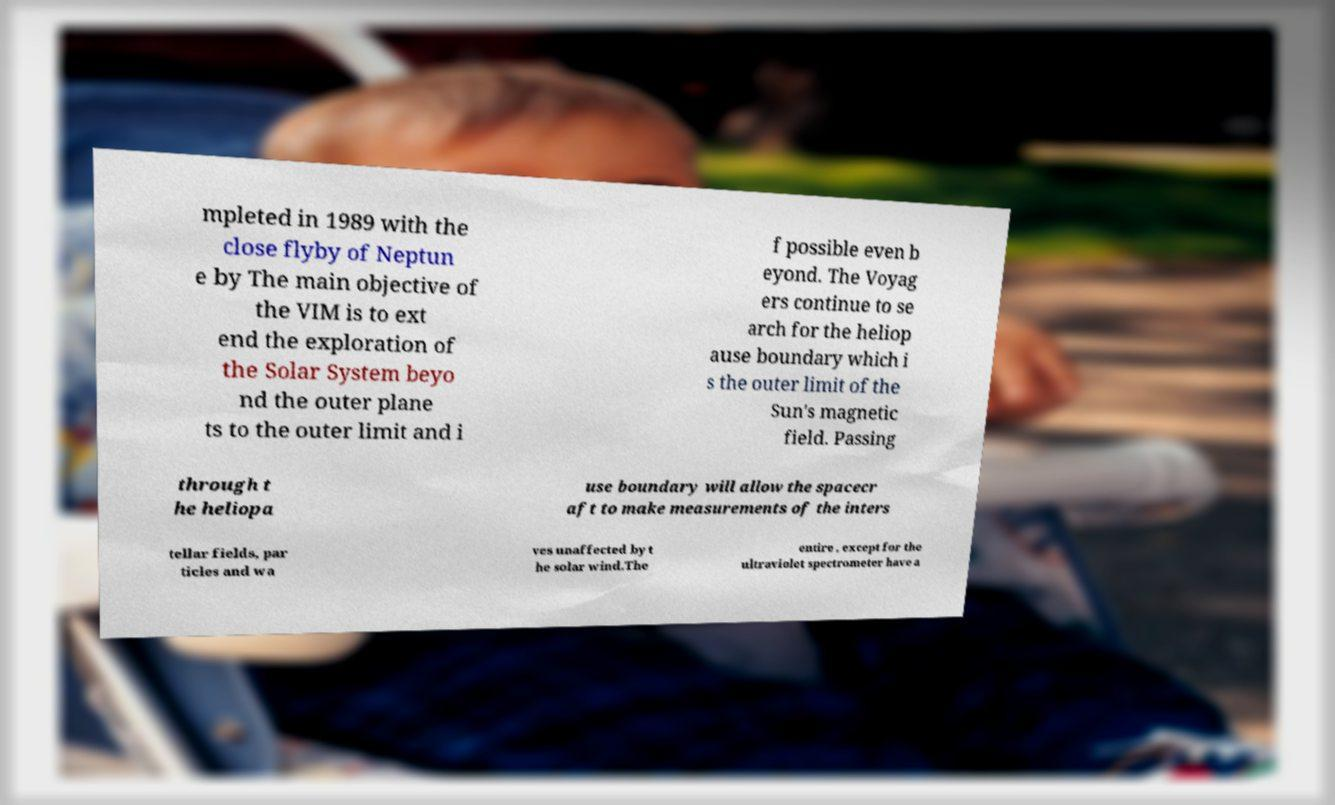For documentation purposes, I need the text within this image transcribed. Could you provide that? mpleted in 1989 with the close flyby of Neptun e by The main objective of the VIM is to ext end the exploration of the Solar System beyo nd the outer plane ts to the outer limit and i f possible even b eyond. The Voyag ers continue to se arch for the heliop ause boundary which i s the outer limit of the Sun's magnetic field. Passing through t he heliopa use boundary will allow the spacecr aft to make measurements of the inters tellar fields, par ticles and wa ves unaffected by t he solar wind.The entire , except for the ultraviolet spectrometer have a 